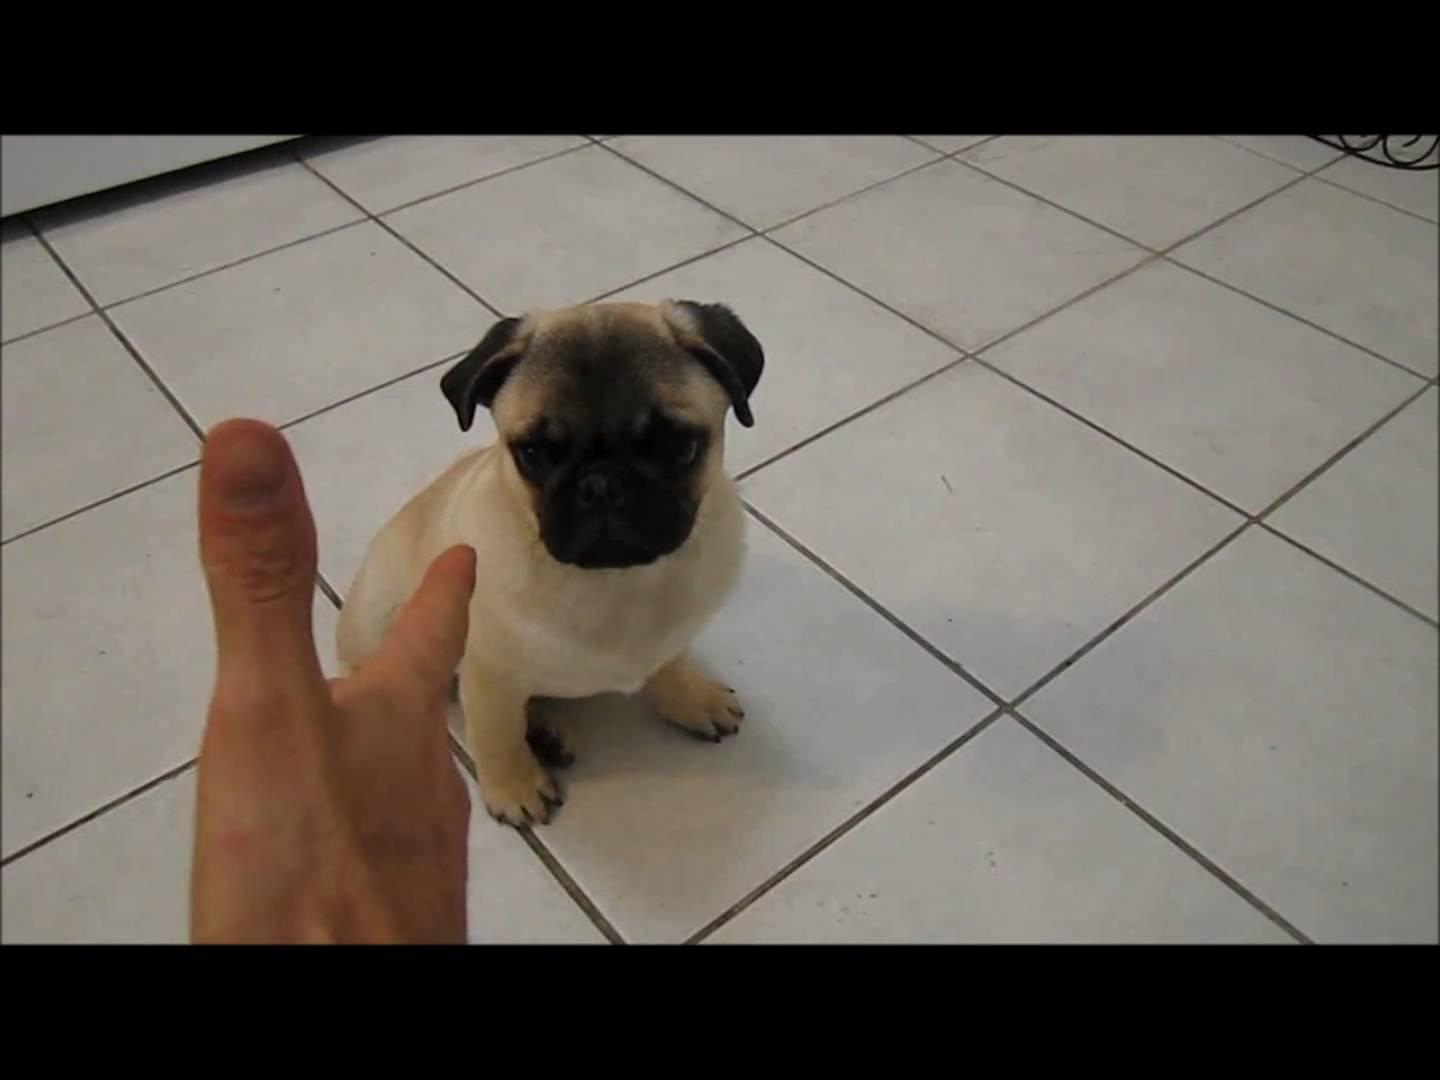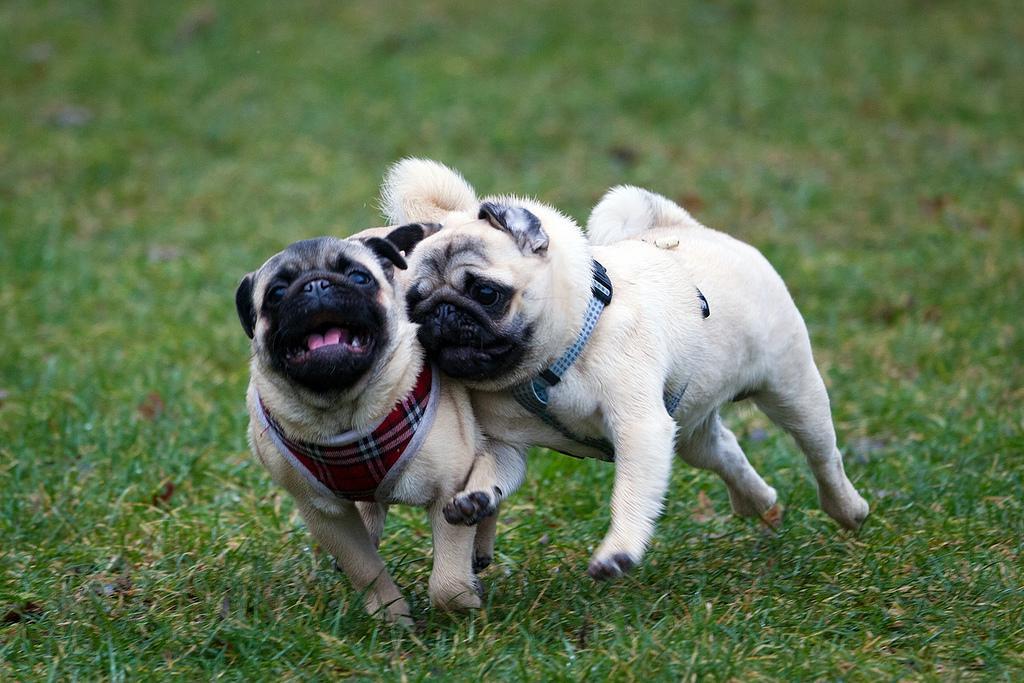The first image is the image on the left, the second image is the image on the right. Examine the images to the left and right. Is the description "The left image contains at least two dogs." accurate? Answer yes or no. No. The first image is the image on the left, the second image is the image on the right. Evaluate the accuracy of this statement regarding the images: "There are exactly 3 dogs depicted.". Is it true? Answer yes or no. Yes. 